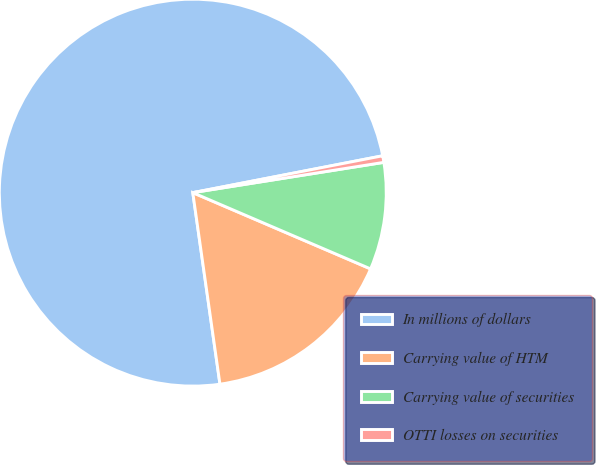Convert chart to OTSL. <chart><loc_0><loc_0><loc_500><loc_500><pie_chart><fcel>In millions of dollars<fcel>Carrying value of HTM<fcel>Carrying value of securities<fcel>OTTI losses on securities<nl><fcel>74.19%<fcel>16.31%<fcel>8.95%<fcel>0.55%<nl></chart> 